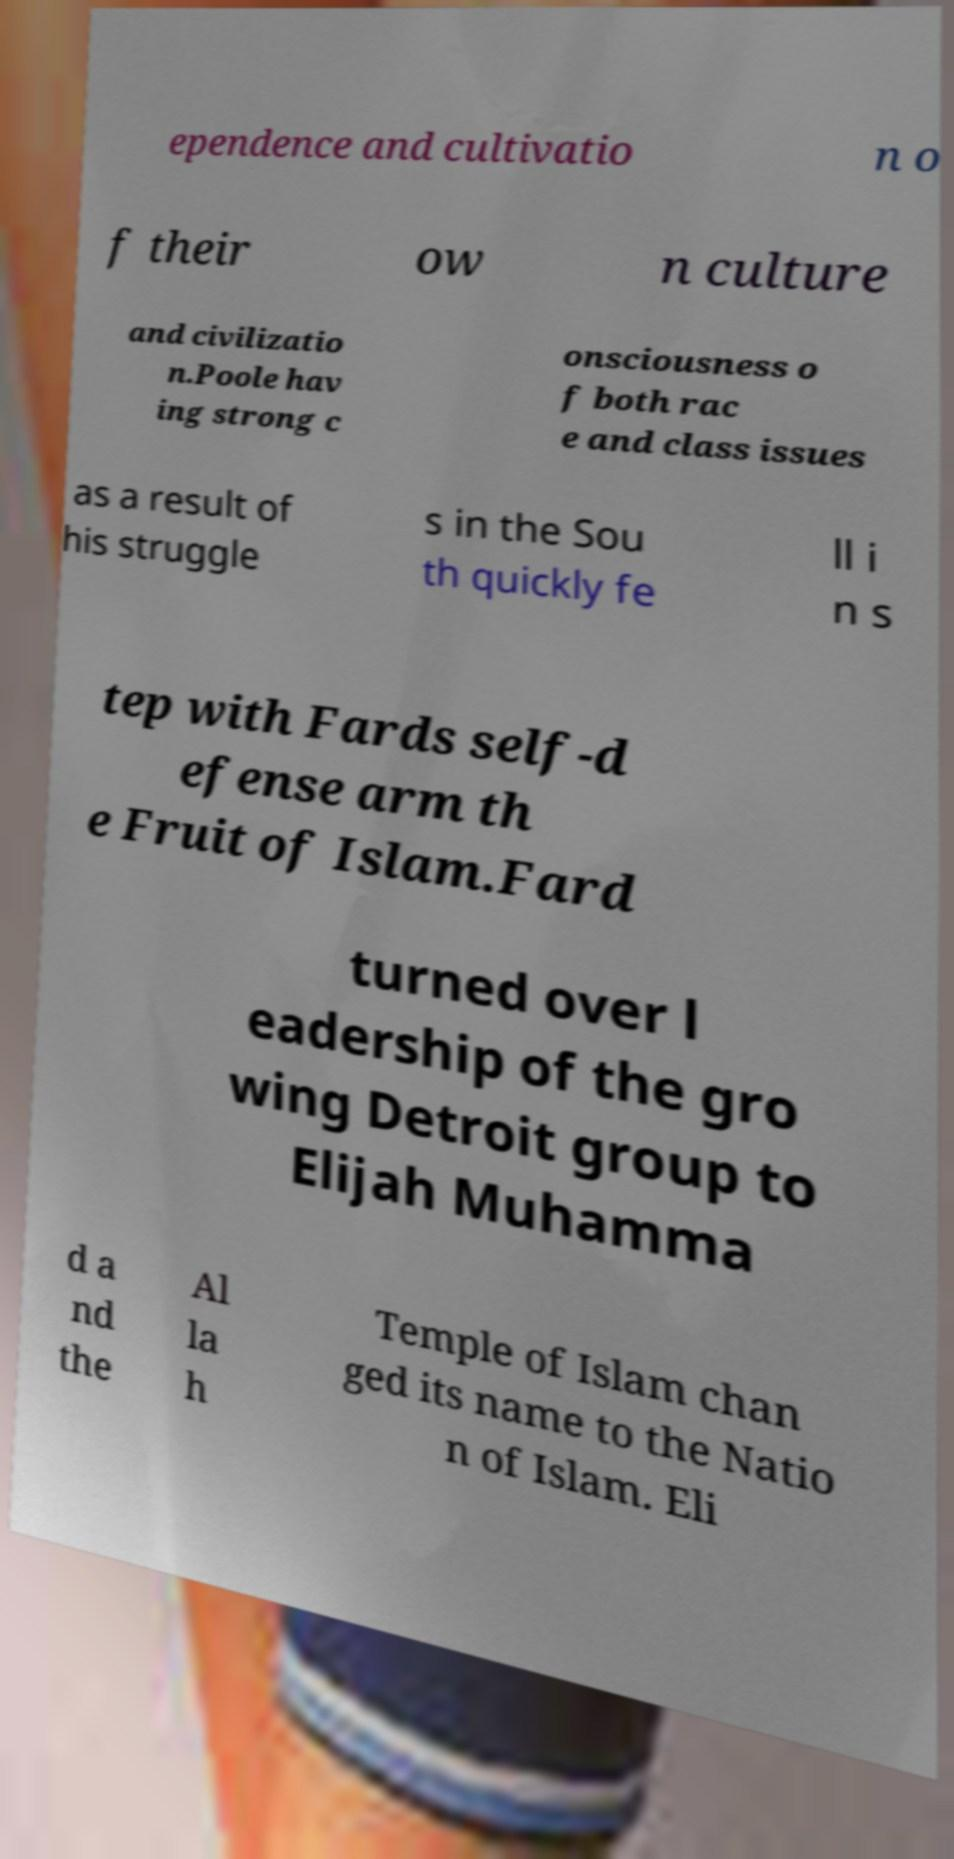Please read and relay the text visible in this image. What does it say? ependence and cultivatio n o f their ow n culture and civilizatio n.Poole hav ing strong c onsciousness o f both rac e and class issues as a result of his struggle s in the Sou th quickly fe ll i n s tep with Fards self-d efense arm th e Fruit of Islam.Fard turned over l eadership of the gro wing Detroit group to Elijah Muhamma d a nd the Al la h Temple of Islam chan ged its name to the Natio n of Islam. Eli 